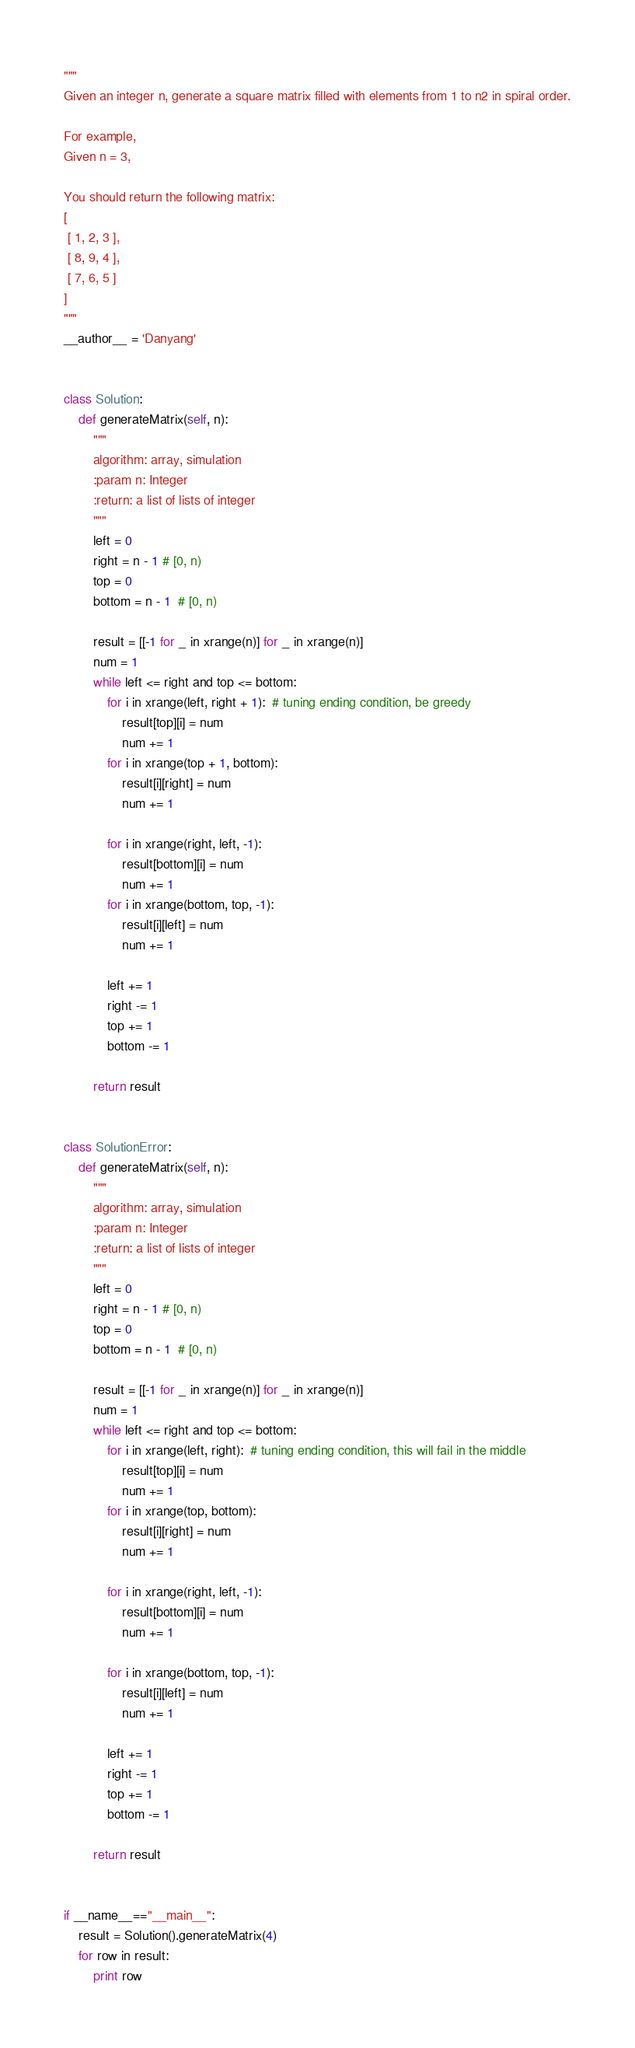<code> <loc_0><loc_0><loc_500><loc_500><_Python_>"""
Given an integer n, generate a square matrix filled with elements from 1 to n2 in spiral order.

For example,
Given n = 3,

You should return the following matrix:
[
 [ 1, 2, 3 ],
 [ 8, 9, 4 ],
 [ 7, 6, 5 ]
]
"""
__author__ = 'Danyang'


class Solution:
    def generateMatrix(self, n):
        """
        algorithm: array, simulation
        :param n: Integer
        :return: a list of lists of integer
        """
        left = 0
        right = n - 1 # [0, n)
        top = 0
        bottom = n - 1  # [0, n)

        result = [[-1 for _ in xrange(n)] for _ in xrange(n)]
        num = 1
        while left <= right and top <= bottom:
            for i in xrange(left, right + 1):  # tuning ending condition, be greedy
                result[top][i] = num
                num += 1
            for i in xrange(top + 1, bottom):
                result[i][right] = num
                num += 1

            for i in xrange(right, left, -1):
                result[bottom][i] = num
                num += 1
            for i in xrange(bottom, top, -1):
                result[i][left] = num
                num += 1

            left += 1
            right -= 1
            top += 1
            bottom -= 1

        return result


class SolutionError:
    def generateMatrix(self, n):
        """
        algorithm: array, simulation
        :param n: Integer
        :return: a list of lists of integer
        """
        left = 0
        right = n - 1 # [0, n)
        top = 0
        bottom = n - 1  # [0, n)

        result = [[-1 for _ in xrange(n)] for _ in xrange(n)]
        num = 1
        while left <= right and top <= bottom:
            for i in xrange(left, right):  # tuning ending condition, this will fail in the middle
                result[top][i] = num
                num += 1
            for i in xrange(top, bottom):
                result[i][right] = num
                num += 1

            for i in xrange(right, left, -1):
                result[bottom][i] = num
                num += 1

            for i in xrange(bottom, top, -1):
                result[i][left] = num
                num += 1

            left += 1
            right -= 1
            top += 1
            bottom -= 1

        return result


if __name__=="__main__":
    result = Solution().generateMatrix(4)
    for row in result:
        print row
</code> 